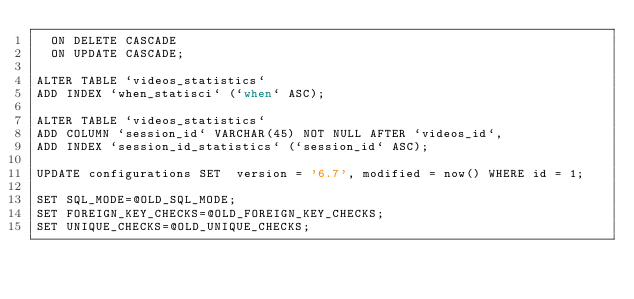Convert code to text. <code><loc_0><loc_0><loc_500><loc_500><_SQL_>  ON DELETE CASCADE
  ON UPDATE CASCADE;

ALTER TABLE `videos_statistics` 
ADD INDEX `when_statisci` (`when` ASC);

ALTER TABLE `videos_statistics` 
ADD COLUMN `session_id` VARCHAR(45) NOT NULL AFTER `videos_id`,
ADD INDEX `session_id_statistics` (`session_id` ASC);

UPDATE configurations SET  version = '6.7', modified = now() WHERE id = 1;

SET SQL_MODE=@OLD_SQL_MODE;
SET FOREIGN_KEY_CHECKS=@OLD_FOREIGN_KEY_CHECKS;
SET UNIQUE_CHECKS=@OLD_UNIQUE_CHECKS;
</code> 